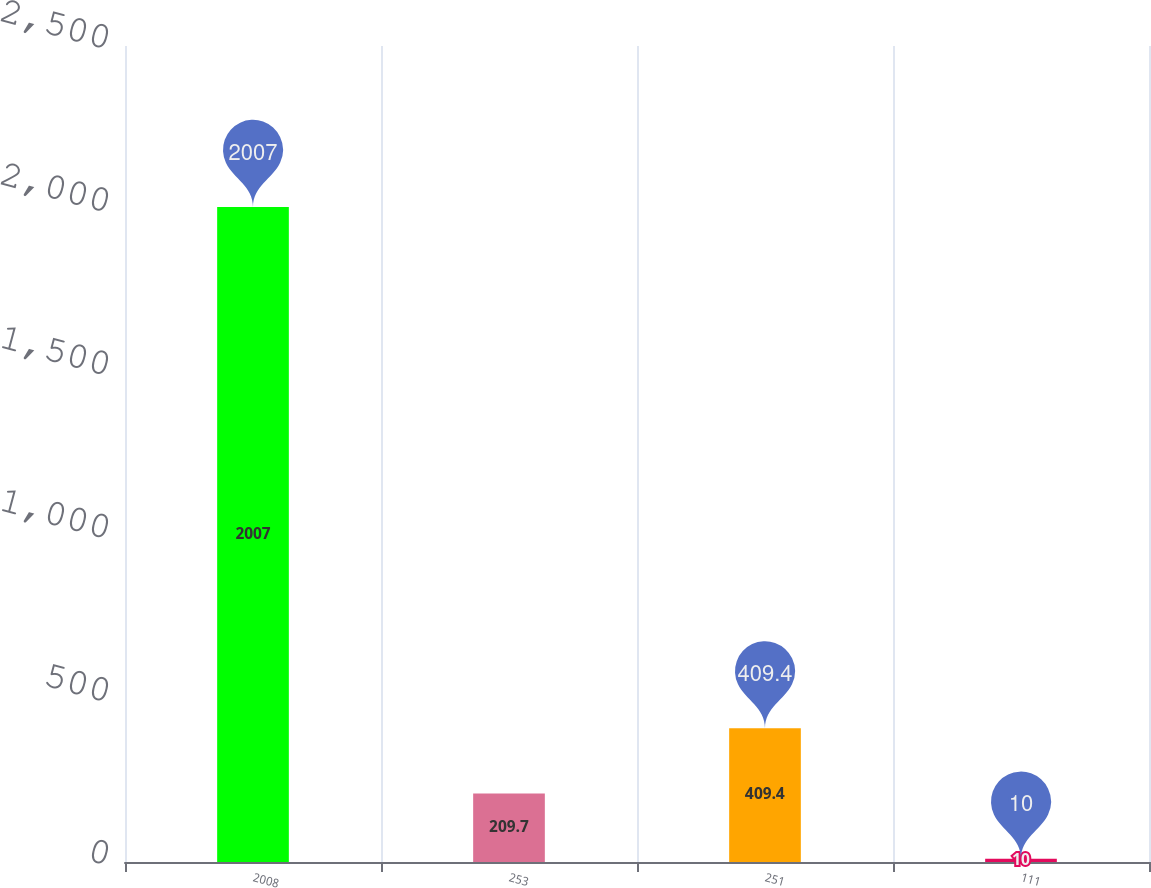<chart> <loc_0><loc_0><loc_500><loc_500><bar_chart><fcel>2008<fcel>253<fcel>251<fcel>111<nl><fcel>2007<fcel>209.7<fcel>409.4<fcel>10<nl></chart> 